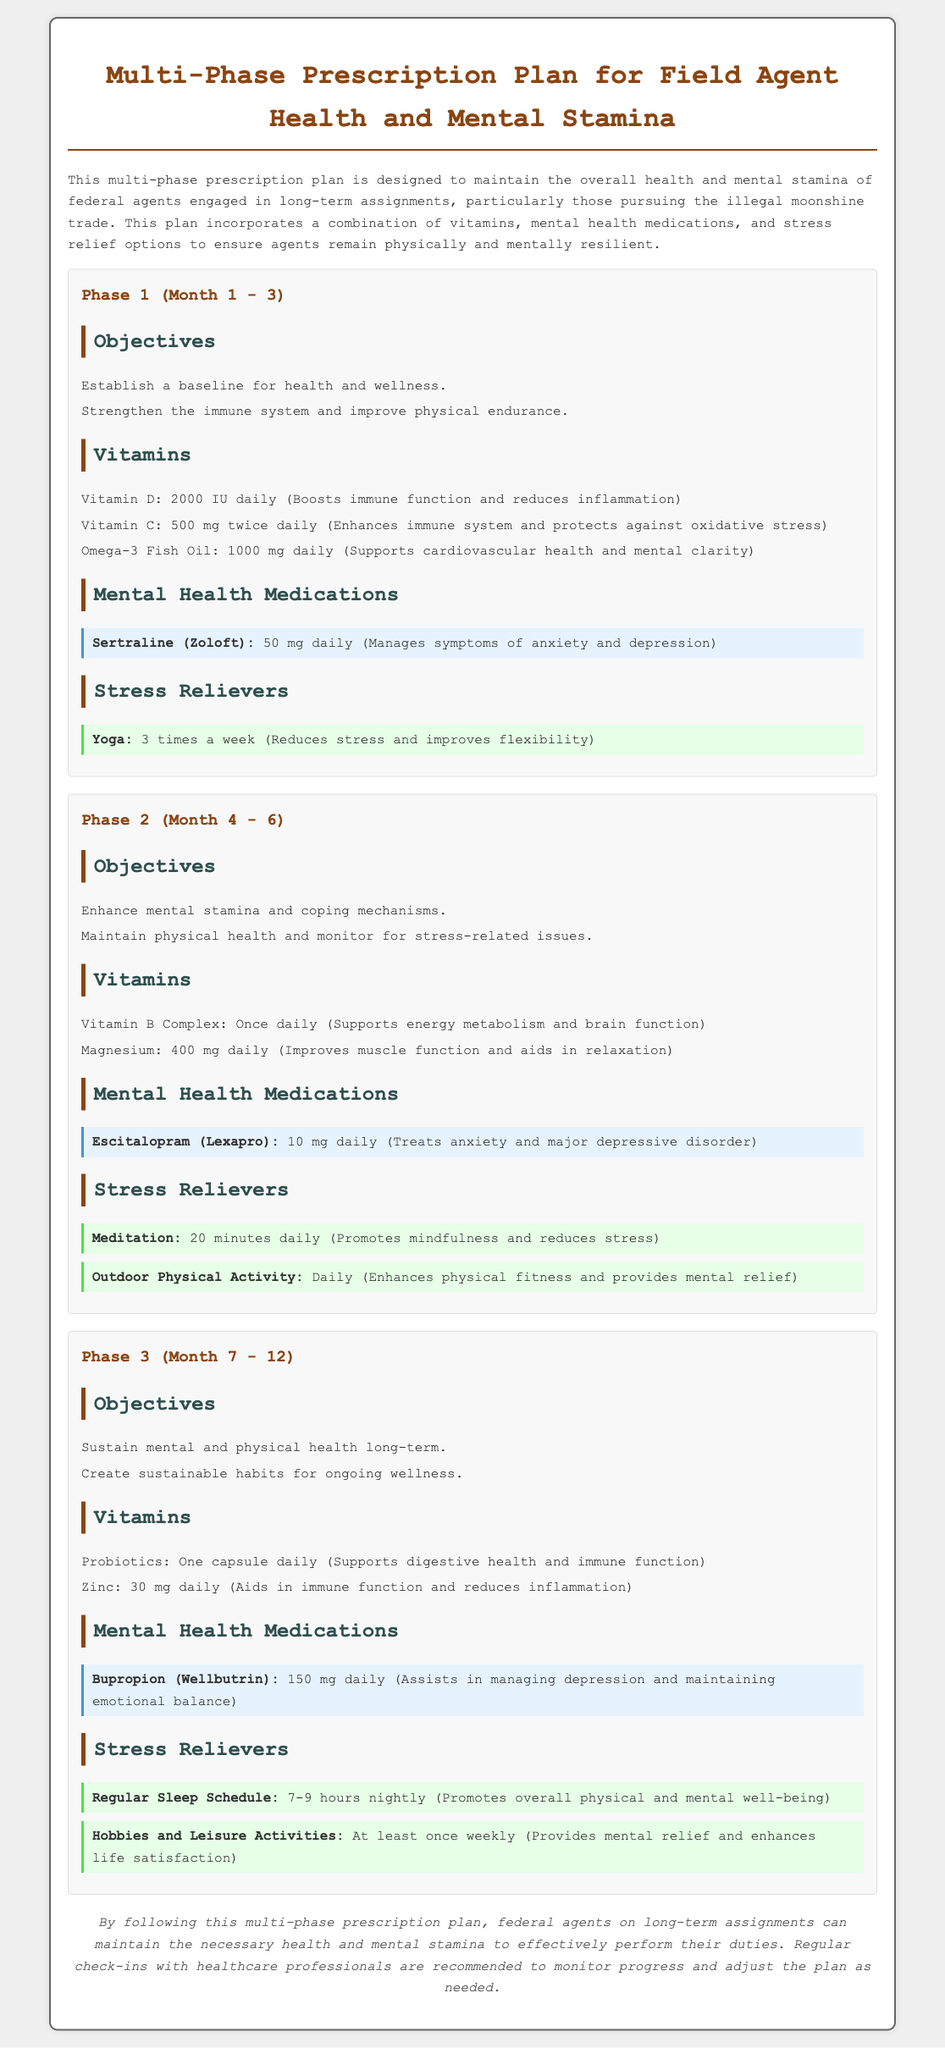What is the title of the document? The title can be found at the top of the document, which states "Multi-Phase Prescription Plan for Field Agent Health and Mental Stamina."
Answer: Multi-Phase Prescription Plan for Field Agent Health and Mental Stamina What is the primary focus of the prescription plan? The primary focus is mentioned in the introductory paragraph, emphasizing the maintenance of overall health and mental stamina for field agents.
Answer: Overall health and mental stamina How many phases are outlined in the prescription plan? The document specifies three distinct phases that are designed for different time periods.
Answer: Three What vitamin is recommended in Phase 1 for immune function? The document lists Vitamin D as a recommended supplement for boosting immune function in Phase 1.
Answer: Vitamin D How much Magnesium is prescribed in Phase 2? The specific dosage of Magnesium is stated in the Vitamins section of Phase 2, which is 400 mg daily.
Answer: 400 mg daily What is the daily dosage of Escitalopram in Phase 2? The document specifies that Escitalopram is to be taken at a dosage of 10 mg daily in Phase 2.
Answer: 10 mg daily Which activity is suggested as a stress reliever in Phase 1? The document identifies Yoga as a stress-relieving activity recommended in Phase 1.
Answer: Yoga What is the total time span for the prescription plan? The document indicates that the total duration covered by the phases is from Month 1 to Month 12.
Answer: Month 1 to Month 12 What is the conclusion regarding the prescription plan? The conclusion emphasizes the importance of following the plan for health and mental stamina, with a note on regular healthcare check-ins.
Answer: Maintain the necessary health and mental stamina 